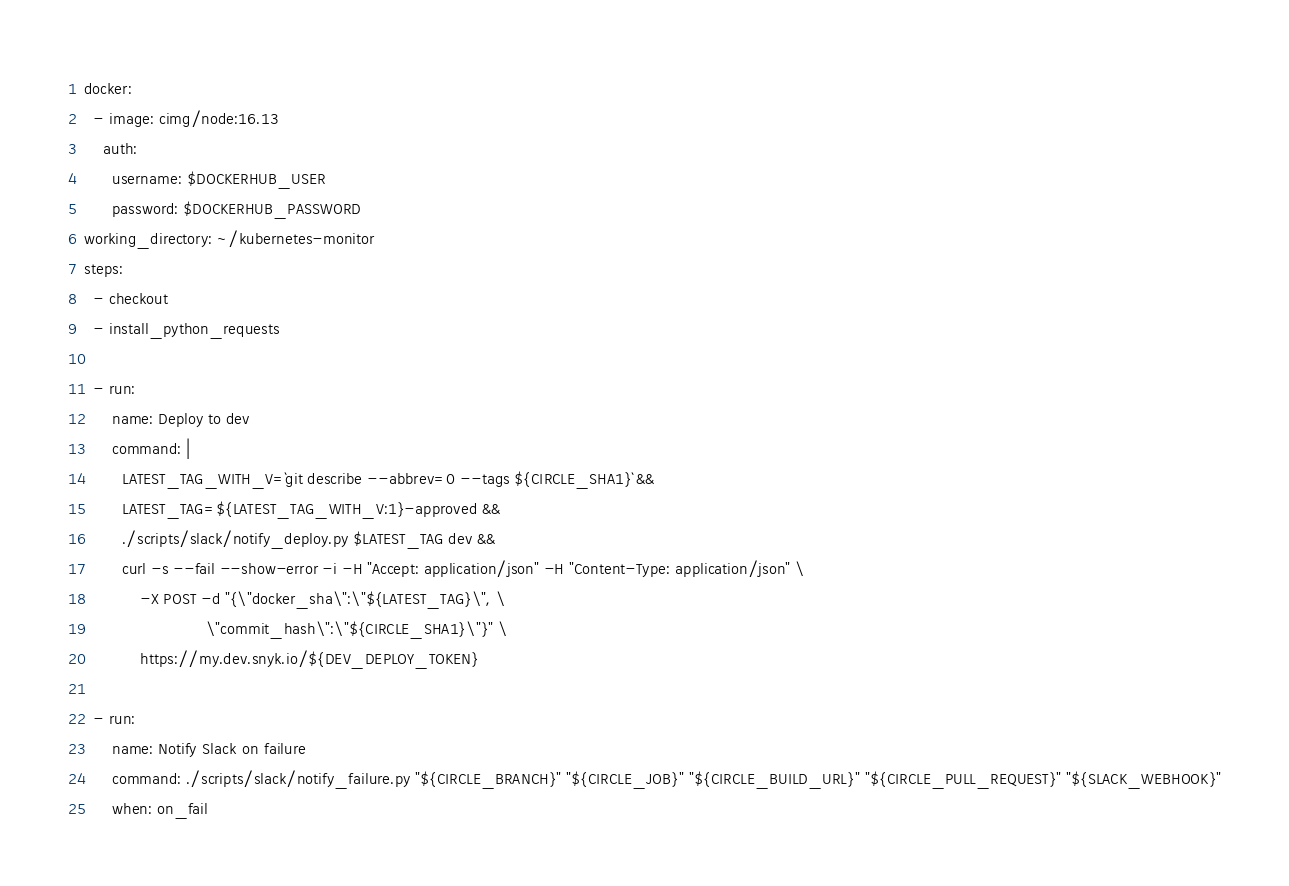<code> <loc_0><loc_0><loc_500><loc_500><_YAML_>docker:
  - image: cimg/node:16.13
    auth:
      username: $DOCKERHUB_USER
      password: $DOCKERHUB_PASSWORD
working_directory: ~/kubernetes-monitor
steps:
  - checkout
  - install_python_requests

  - run:
      name: Deploy to dev
      command: |
        LATEST_TAG_WITH_V=`git describe --abbrev=0 --tags ${CIRCLE_SHA1}` &&
        LATEST_TAG=${LATEST_TAG_WITH_V:1}-approved &&
        ./scripts/slack/notify_deploy.py $LATEST_TAG dev &&
        curl -s --fail --show-error -i -H "Accept: application/json" -H "Content-Type: application/json" \
            -X POST -d "{\"docker_sha\":\"${LATEST_TAG}\", \
                          \"commit_hash\":\"${CIRCLE_SHA1}\"}" \
            https://my.dev.snyk.io/${DEV_DEPLOY_TOKEN}

  - run:
      name: Notify Slack on failure
      command: ./scripts/slack/notify_failure.py "${CIRCLE_BRANCH}" "${CIRCLE_JOB}" "${CIRCLE_BUILD_URL}" "${CIRCLE_PULL_REQUEST}" "${SLACK_WEBHOOK}"
      when: on_fail
</code> 